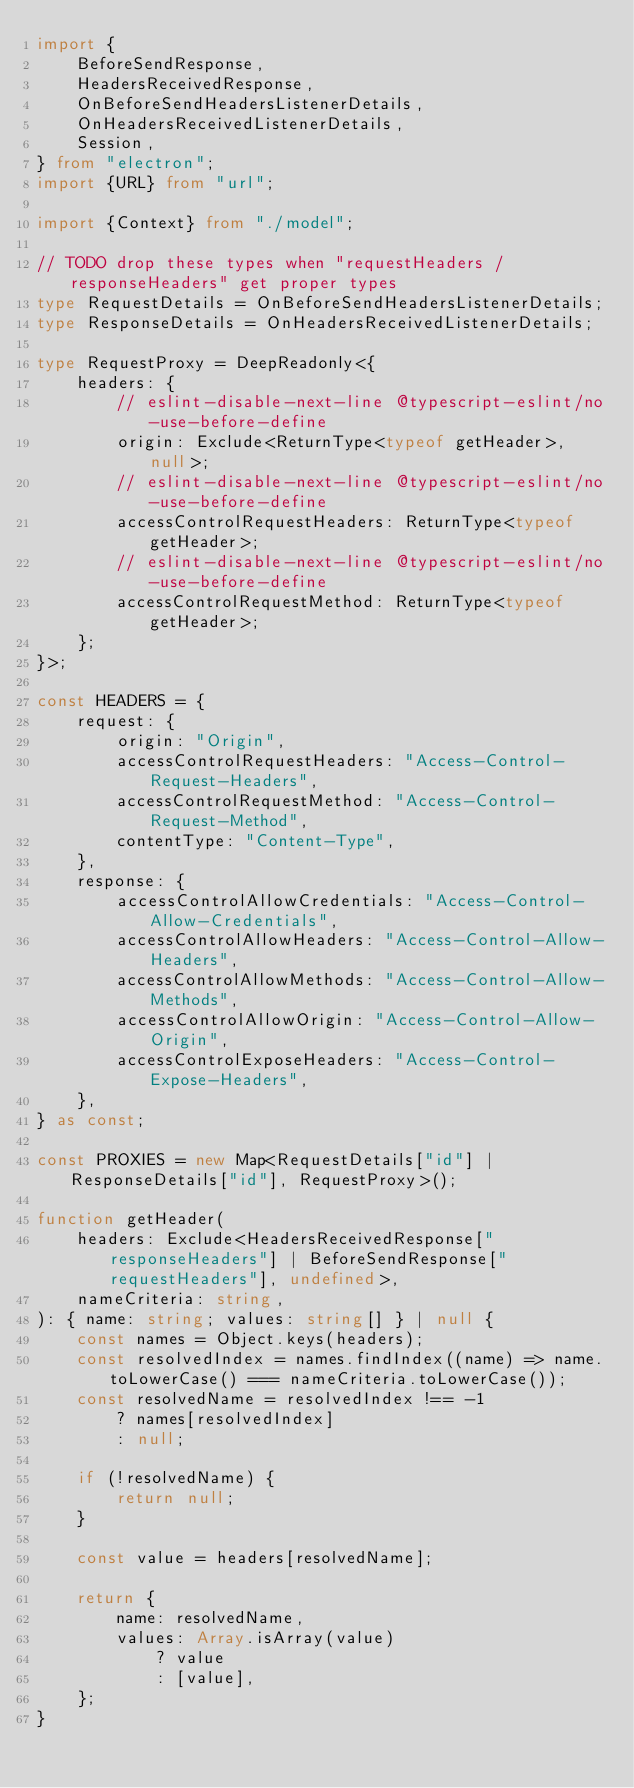Convert code to text. <code><loc_0><loc_0><loc_500><loc_500><_TypeScript_>import {
    BeforeSendResponse,
    HeadersReceivedResponse,
    OnBeforeSendHeadersListenerDetails,
    OnHeadersReceivedListenerDetails,
    Session,
} from "electron";
import {URL} from "url";

import {Context} from "./model";

// TODO drop these types when "requestHeaders / responseHeaders" get proper types
type RequestDetails = OnBeforeSendHeadersListenerDetails;
type ResponseDetails = OnHeadersReceivedListenerDetails;

type RequestProxy = DeepReadonly<{
    headers: {
        // eslint-disable-next-line @typescript-eslint/no-use-before-define
        origin: Exclude<ReturnType<typeof getHeader>, null>;
        // eslint-disable-next-line @typescript-eslint/no-use-before-define
        accessControlRequestHeaders: ReturnType<typeof getHeader>;
        // eslint-disable-next-line @typescript-eslint/no-use-before-define
        accessControlRequestMethod: ReturnType<typeof getHeader>;
    };
}>;

const HEADERS = {
    request: {
        origin: "Origin",
        accessControlRequestHeaders: "Access-Control-Request-Headers",
        accessControlRequestMethod: "Access-Control-Request-Method",
        contentType: "Content-Type",
    },
    response: {
        accessControlAllowCredentials: "Access-Control-Allow-Credentials",
        accessControlAllowHeaders: "Access-Control-Allow-Headers",
        accessControlAllowMethods: "Access-Control-Allow-Methods",
        accessControlAllowOrigin: "Access-Control-Allow-Origin",
        accessControlExposeHeaders: "Access-Control-Expose-Headers",
    },
} as const;

const PROXIES = new Map<RequestDetails["id"] | ResponseDetails["id"], RequestProxy>();

function getHeader(
    headers: Exclude<HeadersReceivedResponse["responseHeaders"] | BeforeSendResponse["requestHeaders"], undefined>,
    nameCriteria: string,
): { name: string; values: string[] } | null {
    const names = Object.keys(headers);
    const resolvedIndex = names.findIndex((name) => name.toLowerCase() === nameCriteria.toLowerCase());
    const resolvedName = resolvedIndex !== -1
        ? names[resolvedIndex]
        : null;

    if (!resolvedName) {
        return null;
    }

    const value = headers[resolvedName];

    return {
        name: resolvedName,
        values: Array.isArray(value)
            ? value
            : [value],
    };
}
</code> 